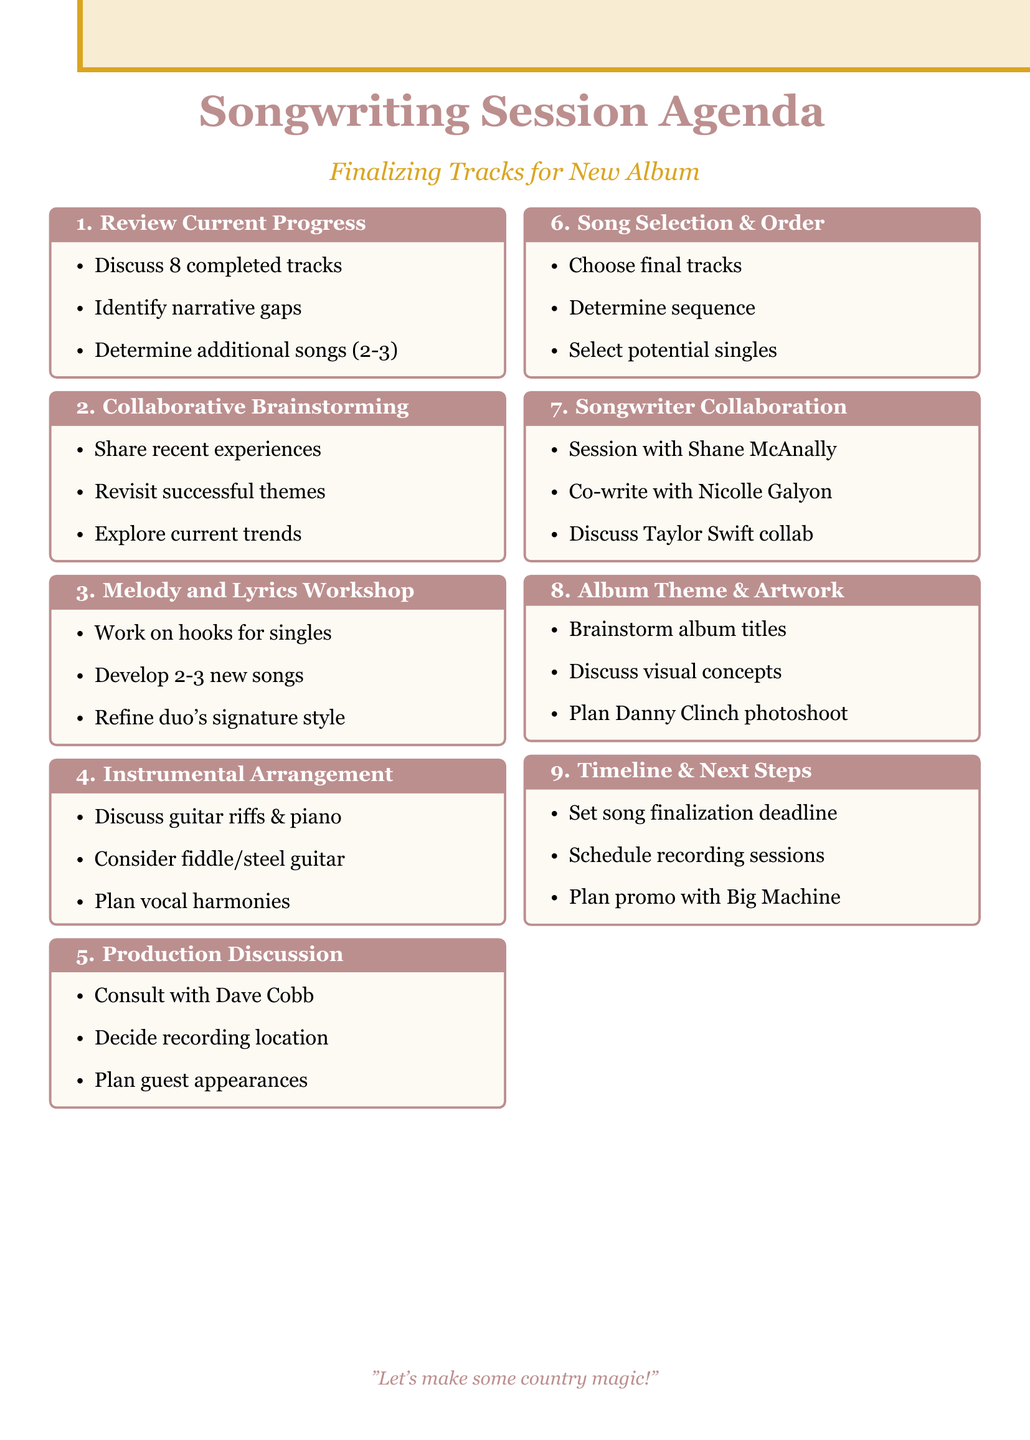What is the title of the document? The title of the document is presented at the top of the agenda.
Answer: Songwriting Session Agenda How many completed tracks are discussed? The agenda lists the number of completed tracks scheduled for discussion.
Answer: 8 Who is the producer mentioned in the production discussion? The document specifies the producer's name who will be consulted regarding the album sound.
Answer: Dave Cobb What is the recommended number of additional songs needed? The session proposes a specific number of additional songs to finalize the album.
Answer: 2-3 Which artist is mentioned for a potential collaboration? The document lists an artist to discuss collaborating with during the introduction.
Answer: Taylor Swift What is one successful theme to revisit for new songs? The document recalls a specific successful song theme from previous albums to inspire new tracks.
Answer: Need You Now What is the ideal sequence's purpose according to the agenda? The agenda states the importance of the sequence in enhancing the album’s overall impact.
Answer: Emotional impact When should the final songs be completed? The agenda sets a deadline for finalizing all songs for the new album.
Answer: Not specified Who will be involved in the ballad co-write? The document specifies a songwriter who is scheduled to co-write a ballad.
Answer: Nicolle Galyon 